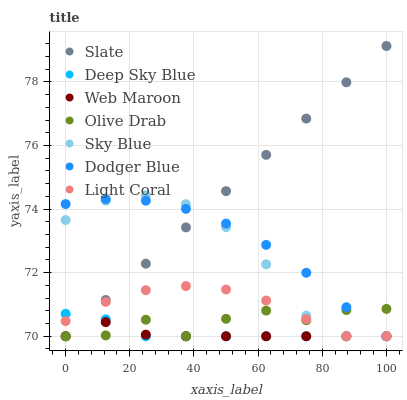Does Web Maroon have the minimum area under the curve?
Answer yes or no. Yes. Does Slate have the maximum area under the curve?
Answer yes or no. Yes. Does Light Coral have the minimum area under the curve?
Answer yes or no. No. Does Light Coral have the maximum area under the curve?
Answer yes or no. No. Is Slate the smoothest?
Answer yes or no. Yes. Is Olive Drab the roughest?
Answer yes or no. Yes. Is Web Maroon the smoothest?
Answer yes or no. No. Is Web Maroon the roughest?
Answer yes or no. No. Does Slate have the lowest value?
Answer yes or no. Yes. Does Slate have the highest value?
Answer yes or no. Yes. Does Light Coral have the highest value?
Answer yes or no. No. Does Web Maroon intersect Sky Blue?
Answer yes or no. Yes. Is Web Maroon less than Sky Blue?
Answer yes or no. No. Is Web Maroon greater than Sky Blue?
Answer yes or no. No. 